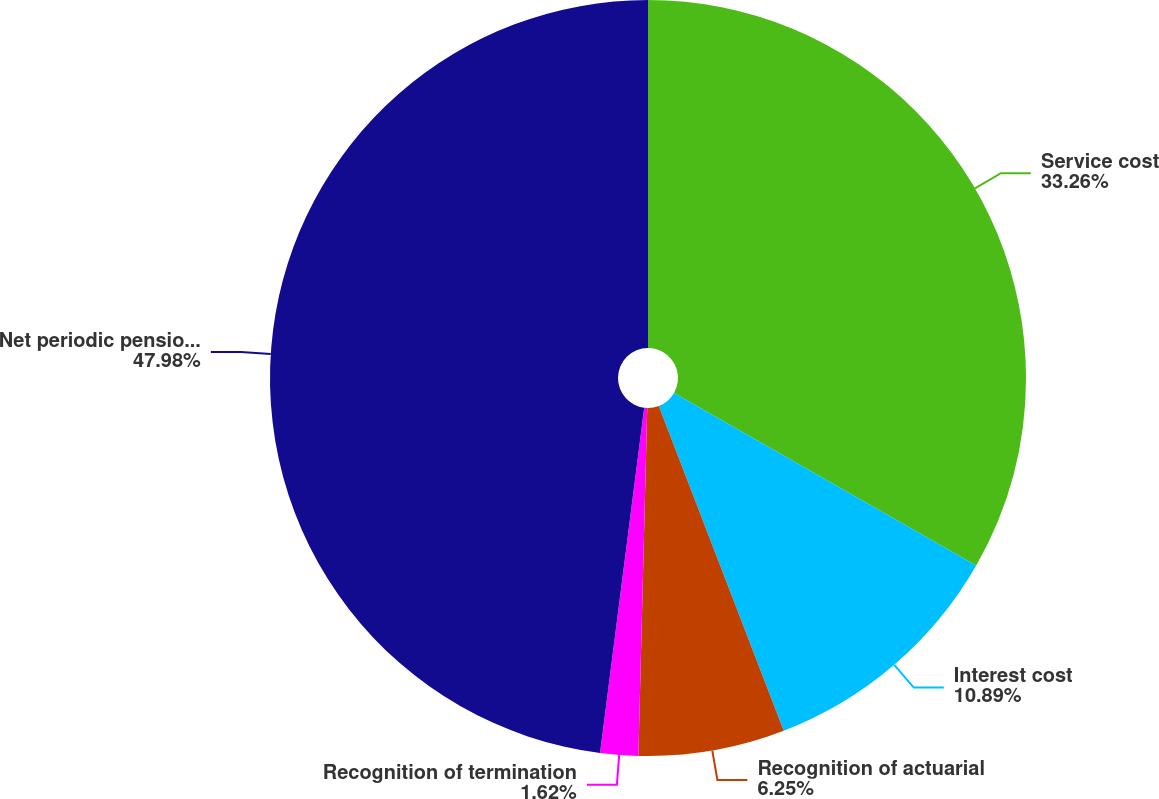Convert chart. <chart><loc_0><loc_0><loc_500><loc_500><pie_chart><fcel>Service cost<fcel>Interest cost<fcel>Recognition of actuarial<fcel>Recognition of termination<fcel>Net periodic pension expense<nl><fcel>33.26%<fcel>10.89%<fcel>6.25%<fcel>1.62%<fcel>47.97%<nl></chart> 